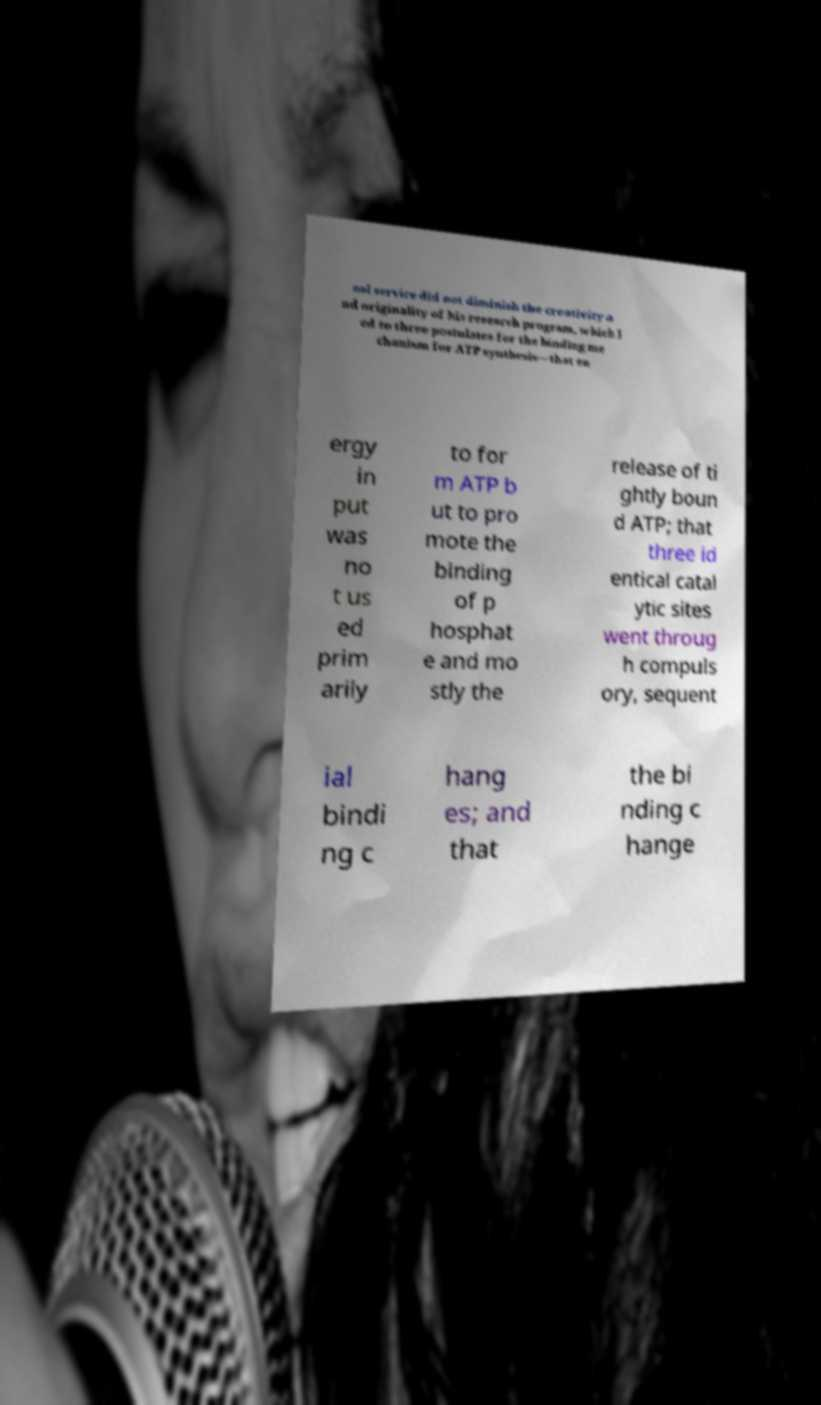Please read and relay the text visible in this image. What does it say? nal service did not diminish the creativity a nd originality of his research program, which l ed to three postulates for the binding me chanism for ATP synthesis—that en ergy in put was no t us ed prim arily to for m ATP b ut to pro mote the binding of p hosphat e and mo stly the release of ti ghtly boun d ATP; that three id entical catal ytic sites went throug h compuls ory, sequent ial bindi ng c hang es; and that the bi nding c hange 